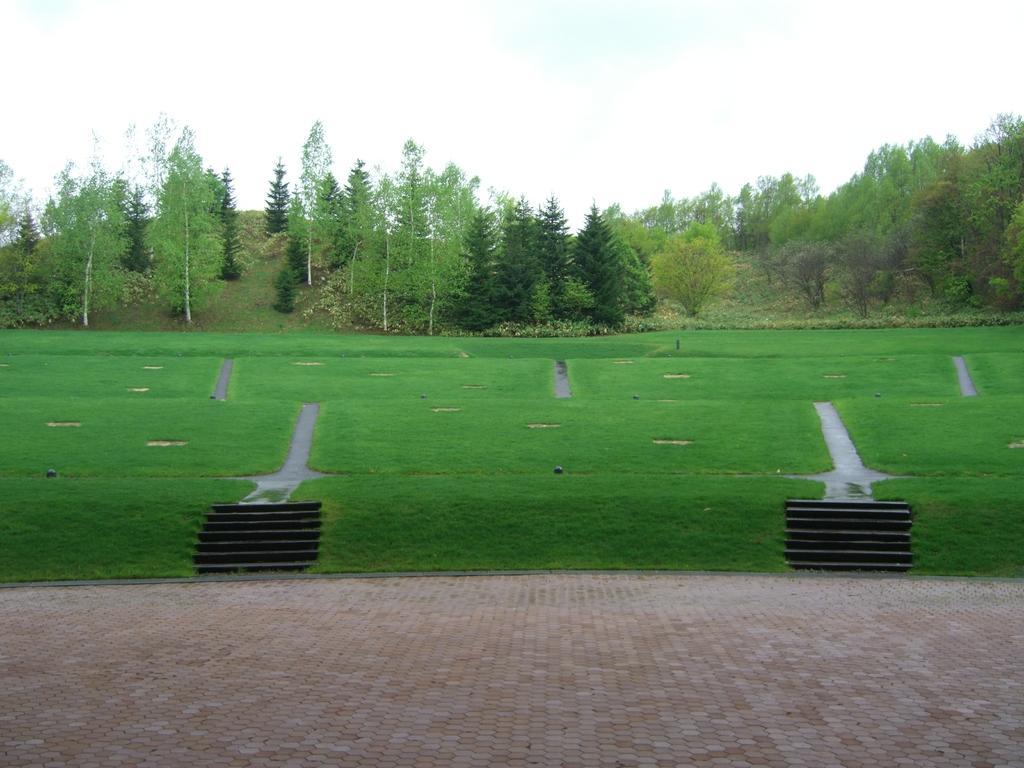How would you summarize this image in a sentence or two? This is an outside view. At the bottom, I can see the floor. In the middle of the image there is a lawn. On the right and left sides of the image there are few stairs. In the background there are many trees. At the top of the image I can see the sky. 